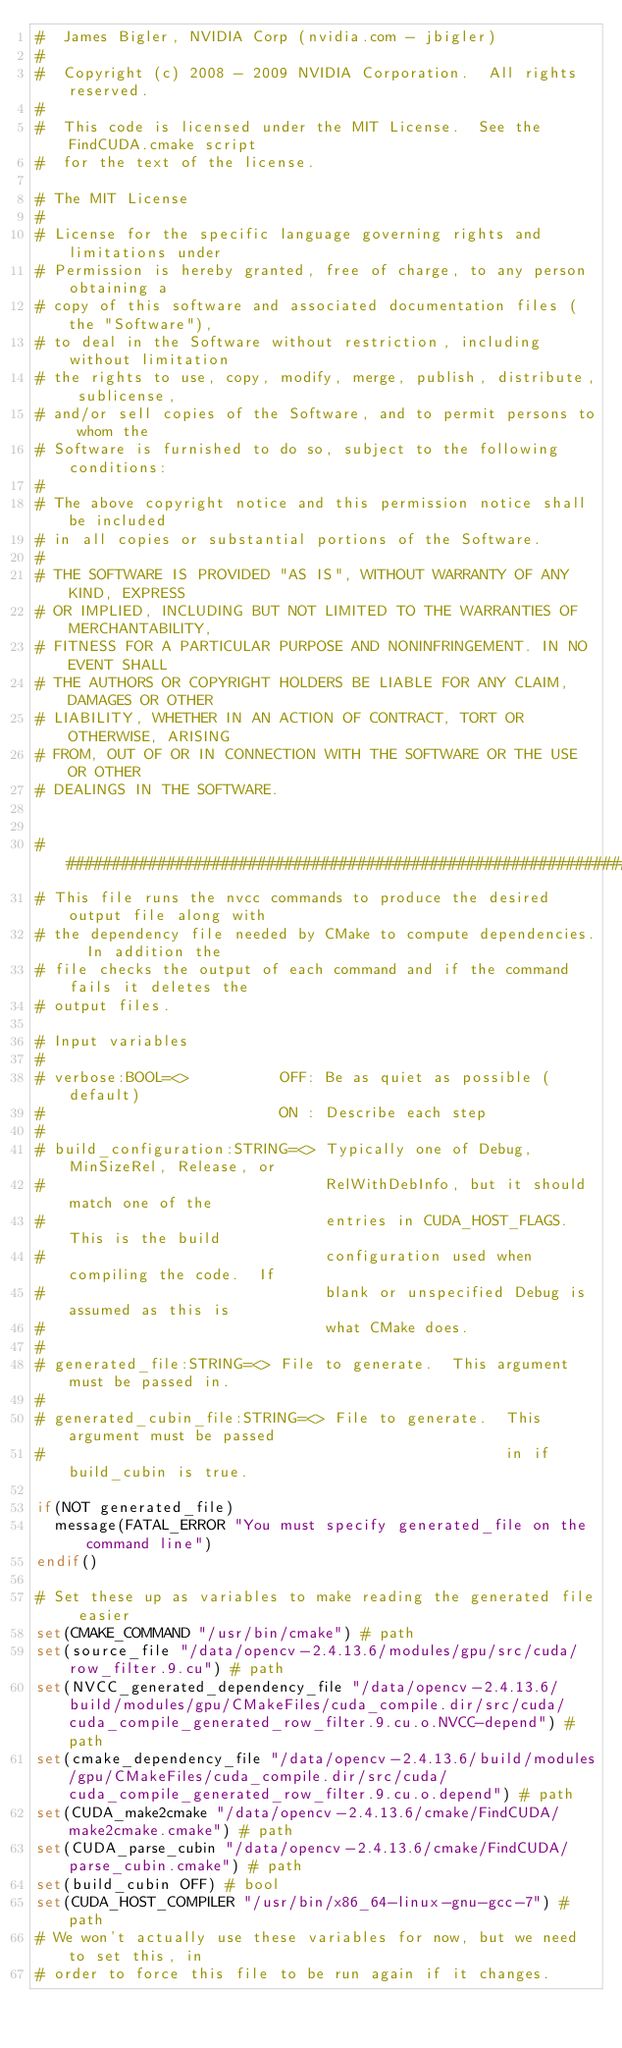Convert code to text. <code><loc_0><loc_0><loc_500><loc_500><_CMake_>#  James Bigler, NVIDIA Corp (nvidia.com - jbigler)
#
#  Copyright (c) 2008 - 2009 NVIDIA Corporation.  All rights reserved.
#
#  This code is licensed under the MIT License.  See the FindCUDA.cmake script
#  for the text of the license.

# The MIT License
#
# License for the specific language governing rights and limitations under
# Permission is hereby granted, free of charge, to any person obtaining a
# copy of this software and associated documentation files (the "Software"),
# to deal in the Software without restriction, including without limitation
# the rights to use, copy, modify, merge, publish, distribute, sublicense,
# and/or sell copies of the Software, and to permit persons to whom the
# Software is furnished to do so, subject to the following conditions:
#
# The above copyright notice and this permission notice shall be included
# in all copies or substantial portions of the Software.
#
# THE SOFTWARE IS PROVIDED "AS IS", WITHOUT WARRANTY OF ANY KIND, EXPRESS
# OR IMPLIED, INCLUDING BUT NOT LIMITED TO THE WARRANTIES OF MERCHANTABILITY,
# FITNESS FOR A PARTICULAR PURPOSE AND NONINFRINGEMENT. IN NO EVENT SHALL
# THE AUTHORS OR COPYRIGHT HOLDERS BE LIABLE FOR ANY CLAIM, DAMAGES OR OTHER
# LIABILITY, WHETHER IN AN ACTION OF CONTRACT, TORT OR OTHERWISE, ARISING
# FROM, OUT OF OR IN CONNECTION WITH THE SOFTWARE OR THE USE OR OTHER
# DEALINGS IN THE SOFTWARE.


##########################################################################
# This file runs the nvcc commands to produce the desired output file along with
# the dependency file needed by CMake to compute dependencies.  In addition the
# file checks the output of each command and if the command fails it deletes the
# output files.

# Input variables
#
# verbose:BOOL=<>          OFF: Be as quiet as possible (default)
#                          ON : Describe each step
#
# build_configuration:STRING=<> Typically one of Debug, MinSizeRel, Release, or
#                               RelWithDebInfo, but it should match one of the
#                               entries in CUDA_HOST_FLAGS. This is the build
#                               configuration used when compiling the code.  If
#                               blank or unspecified Debug is assumed as this is
#                               what CMake does.
#
# generated_file:STRING=<> File to generate.  This argument must be passed in.
#
# generated_cubin_file:STRING=<> File to generate.  This argument must be passed
#                                                   in if build_cubin is true.

if(NOT generated_file)
  message(FATAL_ERROR "You must specify generated_file on the command line")
endif()

# Set these up as variables to make reading the generated file easier
set(CMAKE_COMMAND "/usr/bin/cmake") # path
set(source_file "/data/opencv-2.4.13.6/modules/gpu/src/cuda/row_filter.9.cu") # path
set(NVCC_generated_dependency_file "/data/opencv-2.4.13.6/build/modules/gpu/CMakeFiles/cuda_compile.dir/src/cuda/cuda_compile_generated_row_filter.9.cu.o.NVCC-depend") # path
set(cmake_dependency_file "/data/opencv-2.4.13.6/build/modules/gpu/CMakeFiles/cuda_compile.dir/src/cuda/cuda_compile_generated_row_filter.9.cu.o.depend") # path
set(CUDA_make2cmake "/data/opencv-2.4.13.6/cmake/FindCUDA/make2cmake.cmake") # path
set(CUDA_parse_cubin "/data/opencv-2.4.13.6/cmake/FindCUDA/parse_cubin.cmake") # path
set(build_cubin OFF) # bool
set(CUDA_HOST_COMPILER "/usr/bin/x86_64-linux-gnu-gcc-7") # path
# We won't actually use these variables for now, but we need to set this, in
# order to force this file to be run again if it changes.</code> 